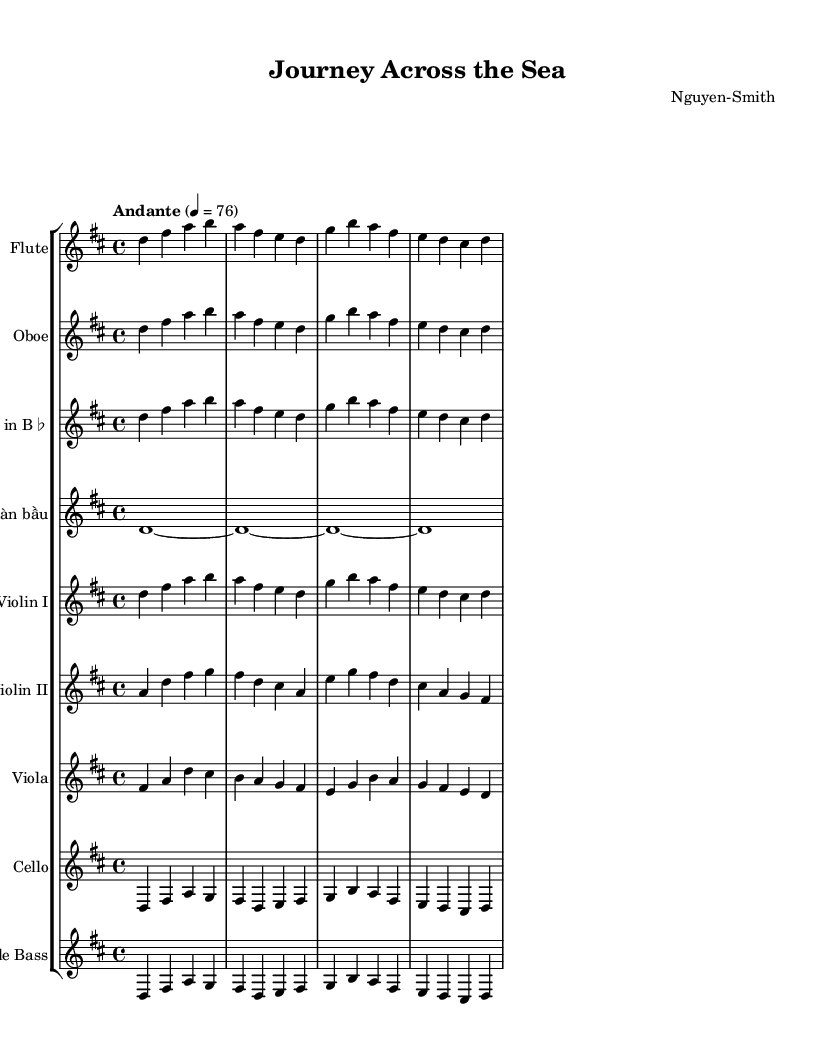What is the key signature of this music? The key signature is indicated at the beginning of the staff, which is two sharps. This corresponds to the D major scale.
Answer: D major What is the time signature of this music? The time signature is indicated after the key signature, where the top number indicates 4 beats per measure and the bottom number indicates that a quarter note gets one beat. Therefore, it is 4/4 time.
Answer: 4/4 What is the tempo marking? The tempo marking is indicated above the staff and is set to "Andante" with a metronome marking of 76 beats per minute. "Andante" suggests a moderately slow tempo.
Answer: Andante Which instrument has the longest sustained note? The Đàn bầu section shows a whole note dimension (d1~), which indicates a long sustained sound, sustained for the entire measure in a single pitch.
Answer: Đàn bầu How many instruments are in this symphonic composition? By counting the distinct staves in the score, we find there are nine different instruments listed, including both Western and Eastern instruments.
Answer: 9 What are the first three notes played by the flute? The flute starts on the note D and progresses through F# and A. These notes are clearly visible at the start of the flute staff.
Answer: D, F#, A What is the role of the Đàn bầu in this symphonic piece? The Đàn bầu, being a string instrument traditionally used in Vietnamese music, provides a unique timbre and adds an Eastern cultural element, contrasting and blending with the Western instrumentation throughout the piece.
Answer: Cultural element 